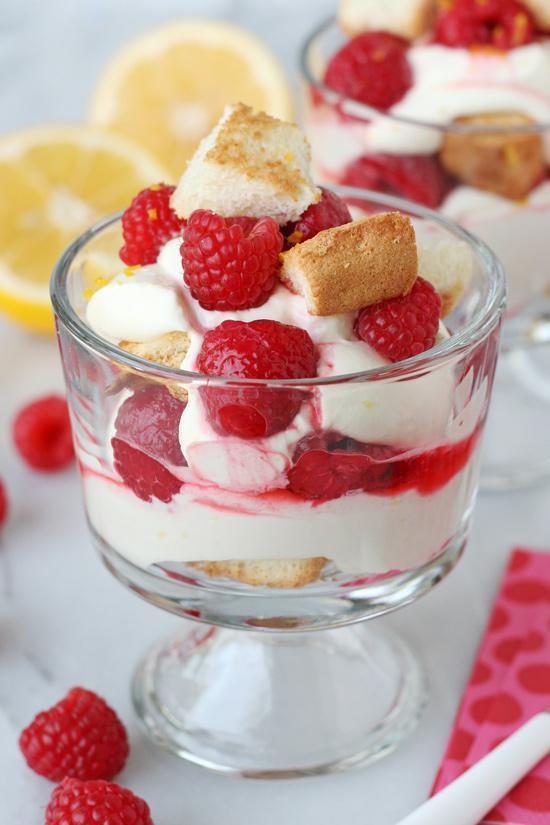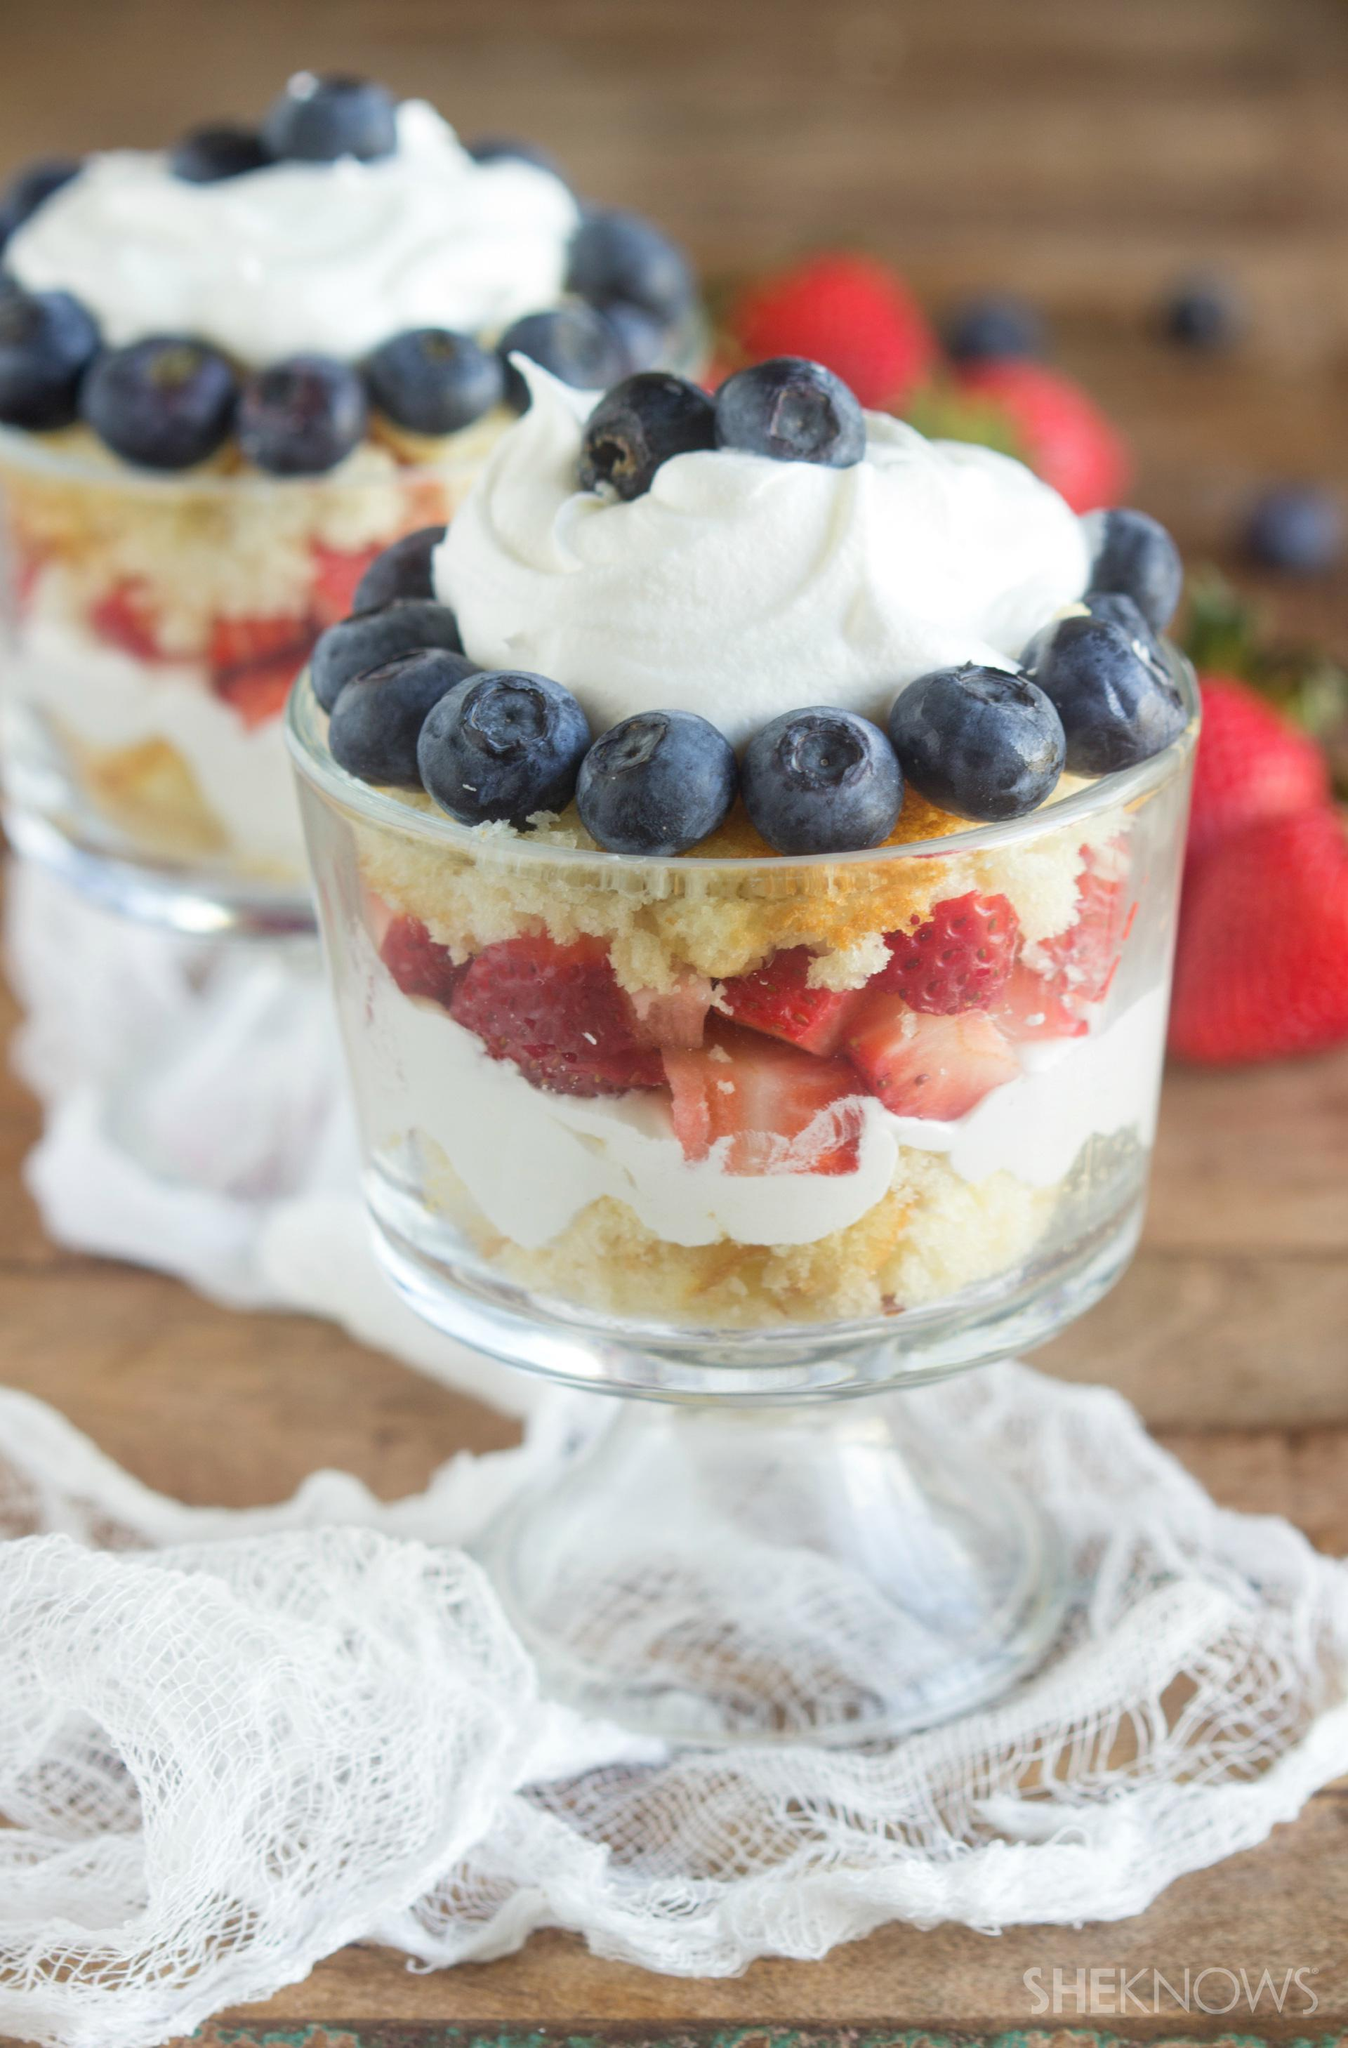The first image is the image on the left, the second image is the image on the right. For the images displayed, is the sentence "One of the images contains a lemon in the background on the table." factually correct? Answer yes or no. Yes. The first image is the image on the left, the second image is the image on the right. For the images shown, is this caption "One image shows a layered dessert garnished with blueberries, and all desserts shown in left and right images are garnished with some type of berry." true? Answer yes or no. Yes. 